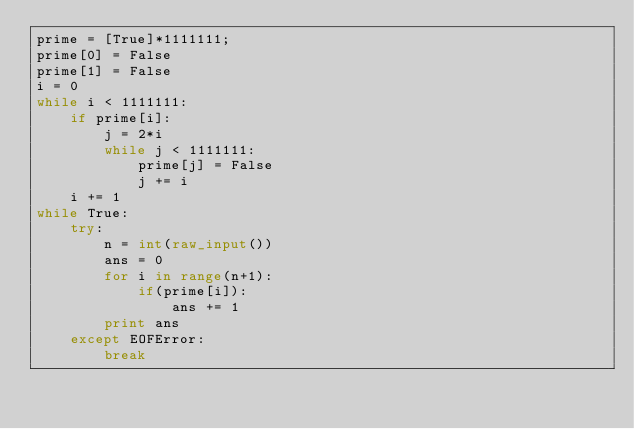Convert code to text. <code><loc_0><loc_0><loc_500><loc_500><_Python_>prime = [True]*1111111;
prime[0] = False
prime[1] = False
i = 0
while i < 1111111:
	if prime[i]:
		j = 2*i
		while j < 1111111:
			prime[j] = False
			j += i
	i += 1
while True:
	try:
		n = int(raw_input())
		ans = 0
		for i in range(n+1):
			if(prime[i]):
				ans += 1
		print ans
	except EOFError:
		break</code> 